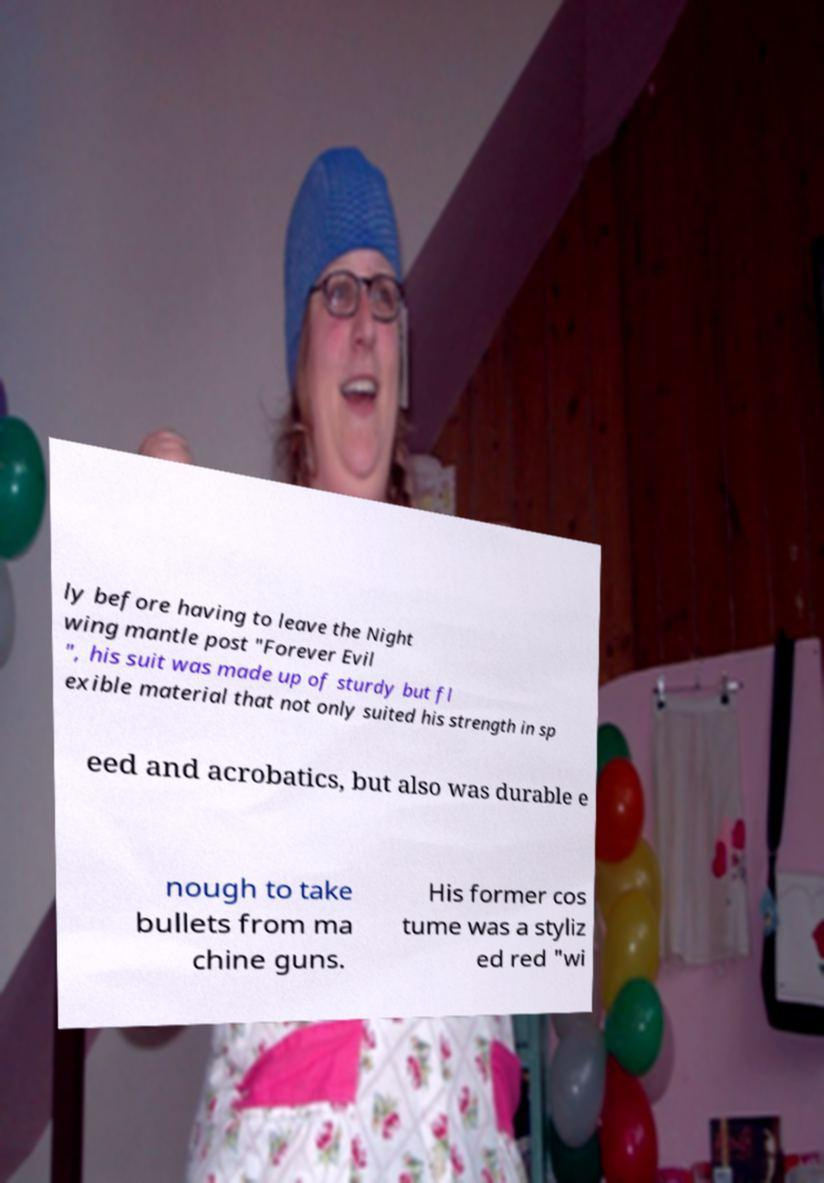Please identify and transcribe the text found in this image. ly before having to leave the Night wing mantle post "Forever Evil ", his suit was made up of sturdy but fl exible material that not only suited his strength in sp eed and acrobatics, but also was durable e nough to take bullets from ma chine guns. His former cos tume was a styliz ed red "wi 